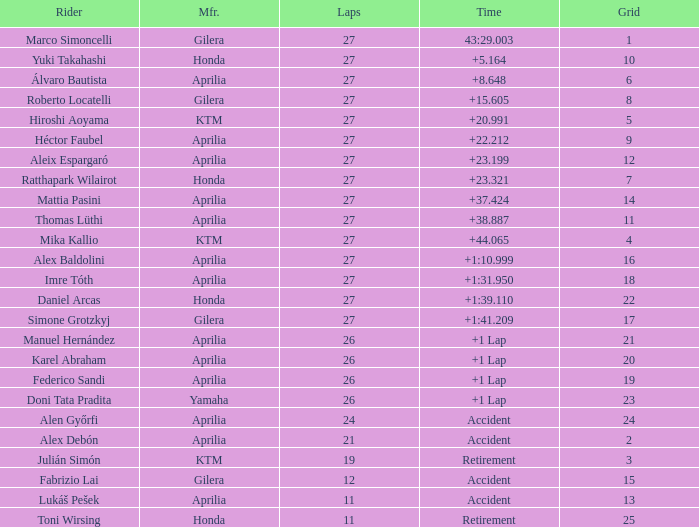Which Manufacturer has a Time of accident and a Grid greater than 15? Aprilia. 